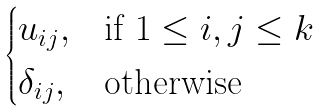<formula> <loc_0><loc_0><loc_500><loc_500>\begin{cases} u _ { i j } , & \text {if $1\leq i,j\leq k$} \\ \delta _ { i j } , & \text {otherwise} \end{cases}</formula> 